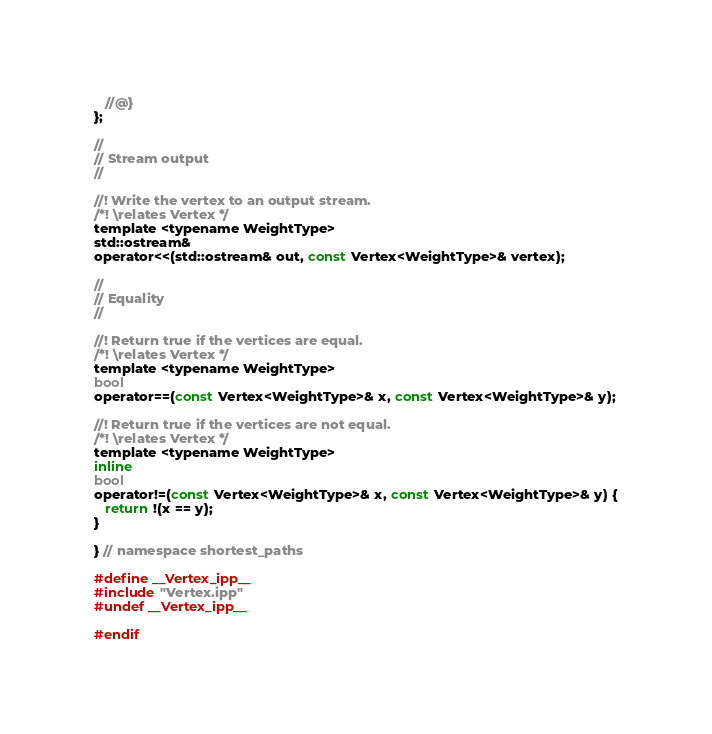<code> <loc_0><loc_0><loc_500><loc_500><_C_>
   //@}
};

//
// Stream output
//

//! Write the vertex to an output stream.
/*! \relates Vertex */
template <typename WeightType>
std::ostream&
operator<<(std::ostream& out, const Vertex<WeightType>& vertex);

//
// Equality
//

//! Return true if the vertices are equal.
/*! \relates Vertex */
template <typename WeightType>
bool
operator==(const Vertex<WeightType>& x, const Vertex<WeightType>& y);

//! Return true if the vertices are not equal.
/*! \relates Vertex */
template <typename WeightType>
inline
bool
operator!=(const Vertex<WeightType>& x, const Vertex<WeightType>& y) {
   return !(x == y);
}

} // namespace shortest_paths

#define __Vertex_ipp__
#include "Vertex.ipp"
#undef __Vertex_ipp__

#endif
</code> 